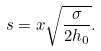Convert formula to latex. <formula><loc_0><loc_0><loc_500><loc_500>s = x \sqrt { \frac { \sigma } { 2 h _ { 0 } } } .</formula> 